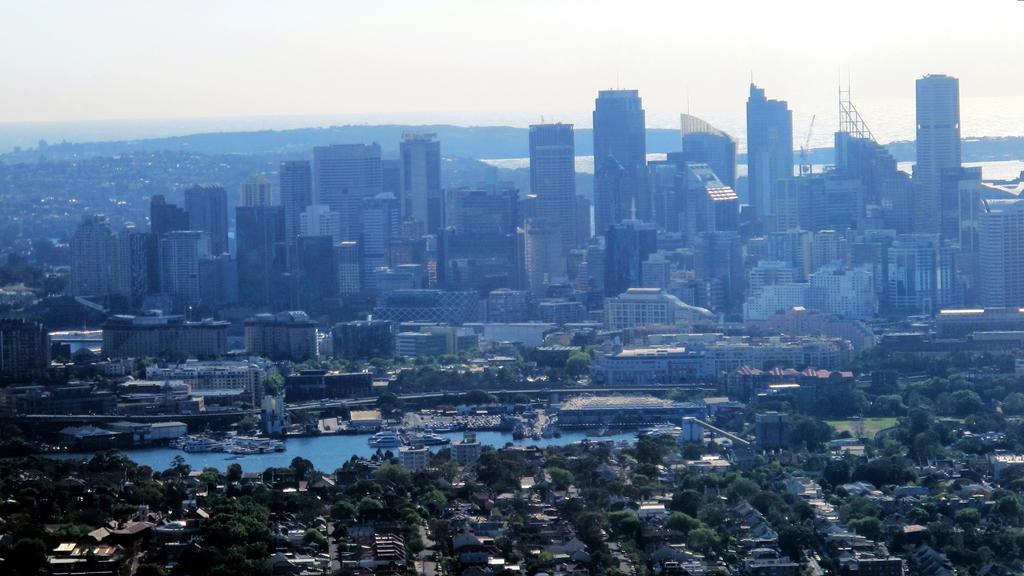Could you give a brief overview of what you see in this image? This is a overview of a city , where we can see buildings, trees and some ships on the water, and there is a sky at the top of this image. 